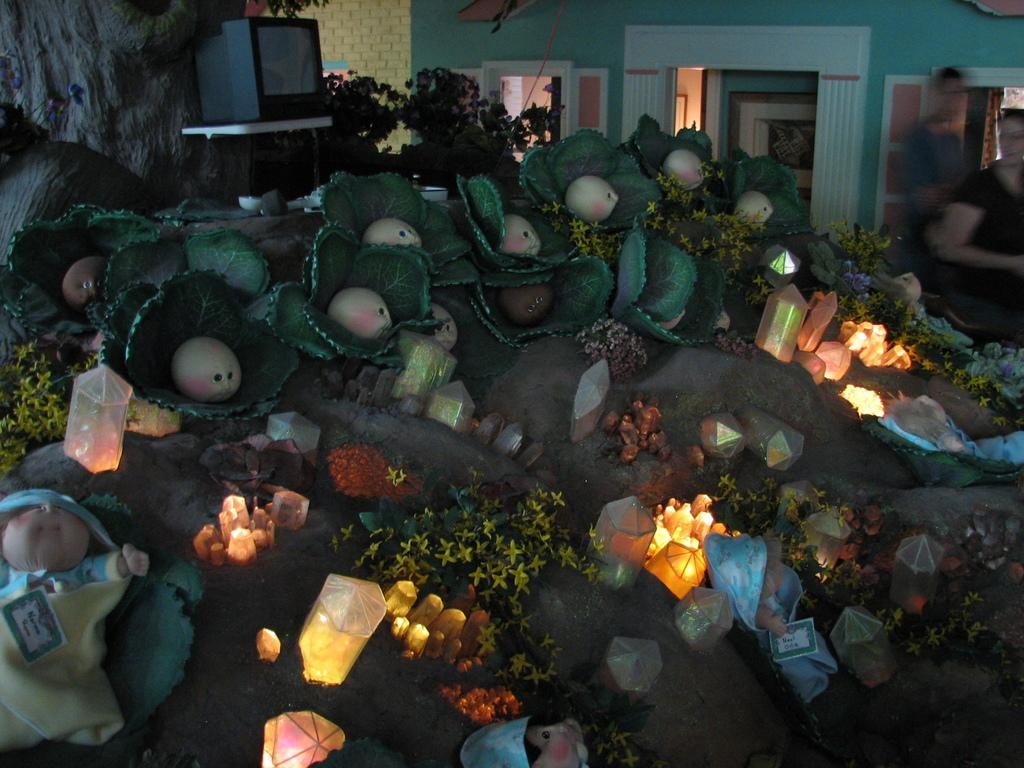What type of objects can be seen in the image that emit light? There are lights in the image. What type of objects can be seen in the image that are meant for play? There are toys in the image. What type of objects can be seen in the image that have flowers? There are plants with flowers in the image. What type of electronic device can be seen in the image? There is a television in the image. How many people are present in the image? There are two persons in the image. What type of architectural feature can be seen in the background of the image? There is a wall in the background of the image. What type of decorative object can be seen in the background of the image? There is a frame in the background of the image. What type of brain can be seen in the image? There is no brain present in the image. What type of cord is connected to the television in the image? There is no cord connected to the television in the image. 